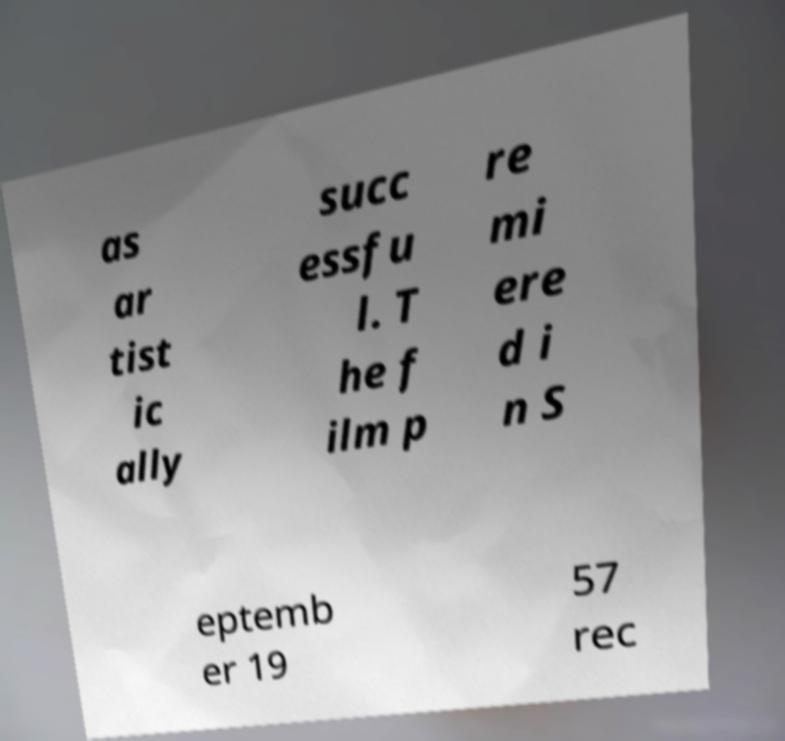I need the written content from this picture converted into text. Can you do that? as ar tist ic ally succ essfu l. T he f ilm p re mi ere d i n S eptemb er 19 57 rec 